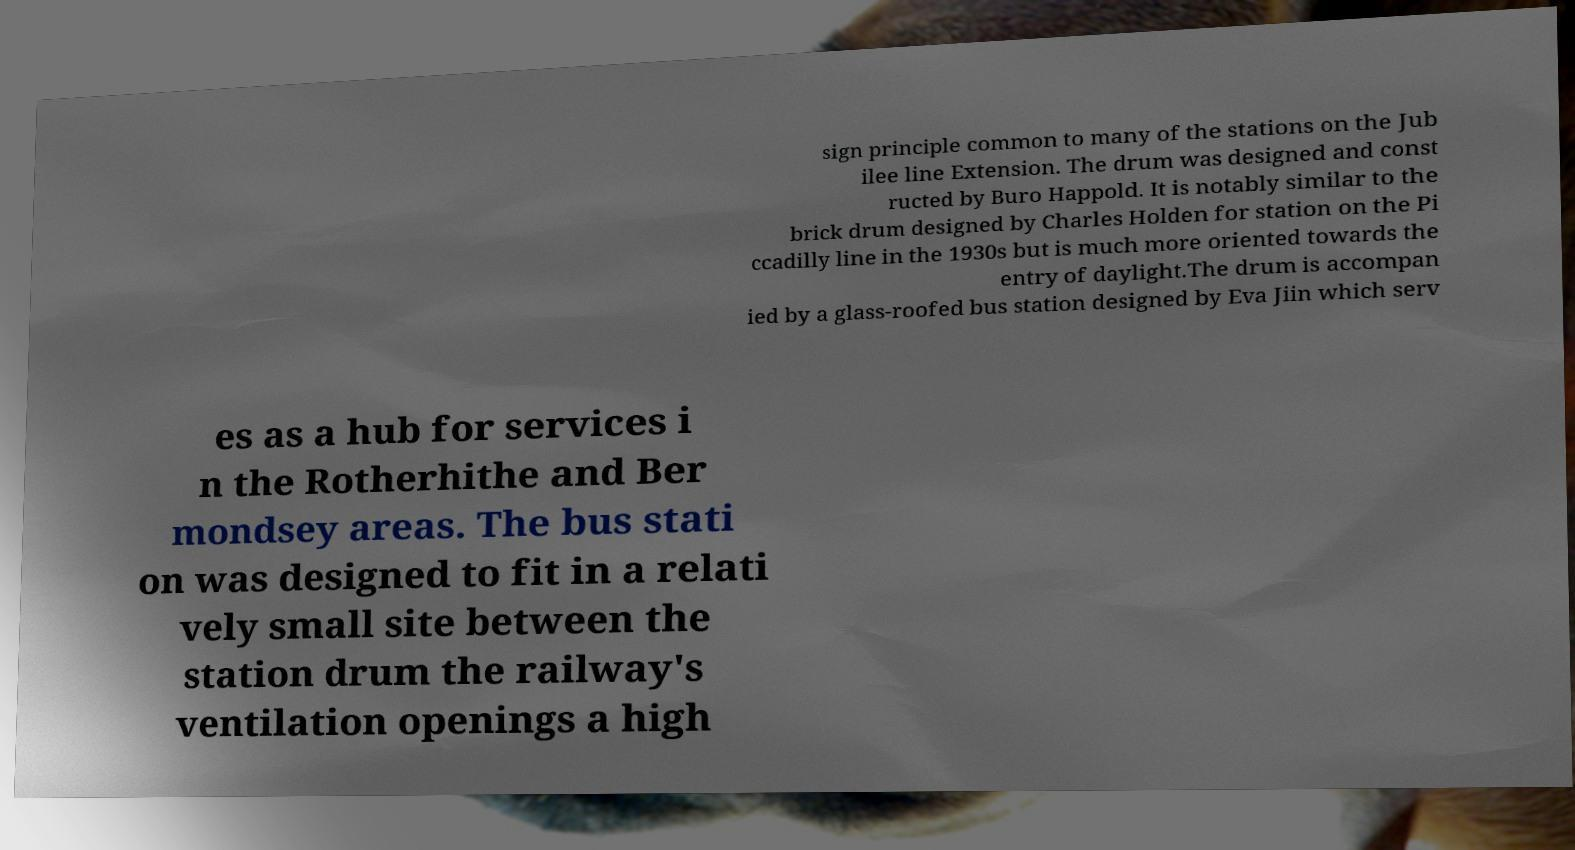Please read and relay the text visible in this image. What does it say? sign principle common to many of the stations on the Jub ilee line Extension. The drum was designed and const ructed by Buro Happold. It is notably similar to the brick drum designed by Charles Holden for station on the Pi ccadilly line in the 1930s but is much more oriented towards the entry of daylight.The drum is accompan ied by a glass-roofed bus station designed by Eva Jiin which serv es as a hub for services i n the Rotherhithe and Ber mondsey areas. The bus stati on was designed to fit in a relati vely small site between the station drum the railway's ventilation openings a high 